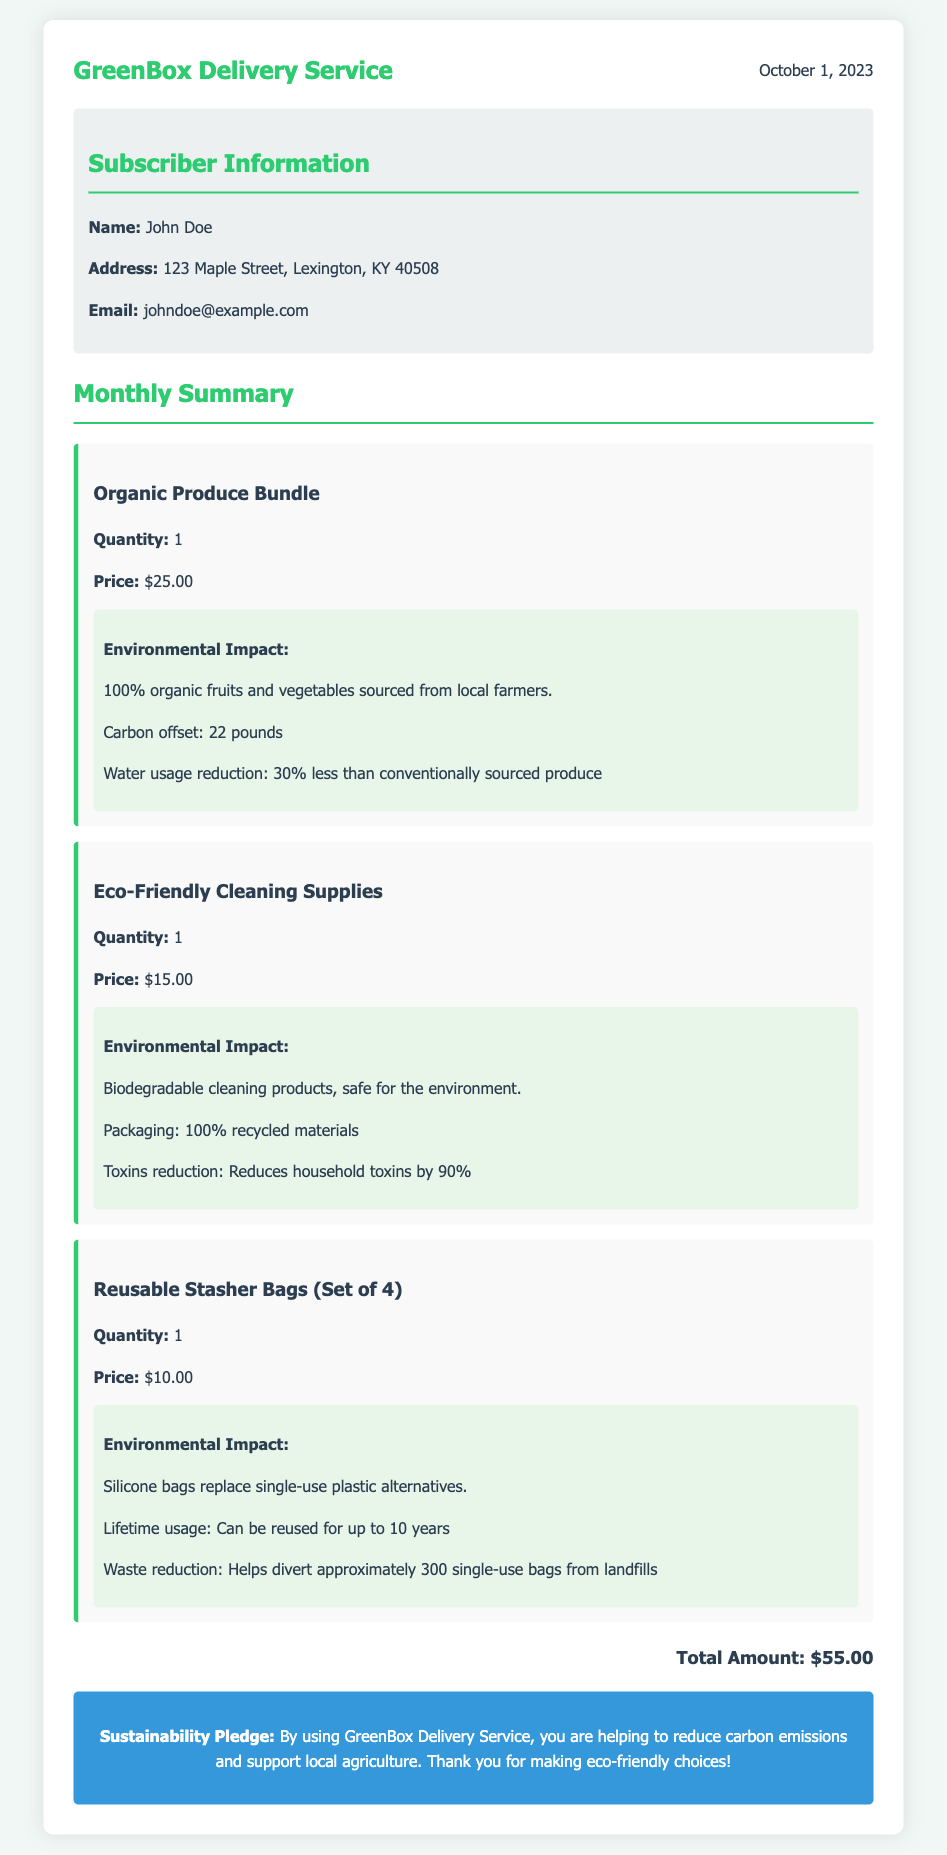What is the name of the subscription service? The name of the subscription service is prominently displayed at the top of the document.
Answer: GreenBox Delivery Service What is the date of the statement? The date is indicated in the header section of the document.
Answer: October 1, 2023 Who is the subscriber? The subscriber information section lists the name of the individual.
Answer: John Doe What is the total amount charged for the subscription? The total amount is summarized at the bottom of the document.
Answer: $55.00 How many pounds of carbon offset are reported for the Organic Produce Bundle? The carbon offset amount is specifically detailed in the Environmental Impact section of the Organic Produce Bundle item.
Answer: 22 pounds What percentage of water usage reduction is achieved with the organic produce? The water usage reduction percentage is clearly stated in the Environmental Impact details of the Organic Produce Bundle.
Answer: 30% What kind of cleaning products are offered in the subscription? The type of cleaning products is specified in the description of one of the items.
Answer: Biodegradable cleaning products How many single-use bags can the Reusable Stasher Bags help divert from landfills? The waste reduction benefit is mentioned in the impact section of the Reusable Stasher Bags.
Answer: 300 What is the lifetime usage of the Reusable Stasher Bags? The document states the potential usage duration for the bags in their description.
Answer: Up to 10 years What is the primary purpose of the Sustainability Pledge? The purpose is outlined in the closure section of the document.
Answer: To reduce carbon emissions and support local agriculture 